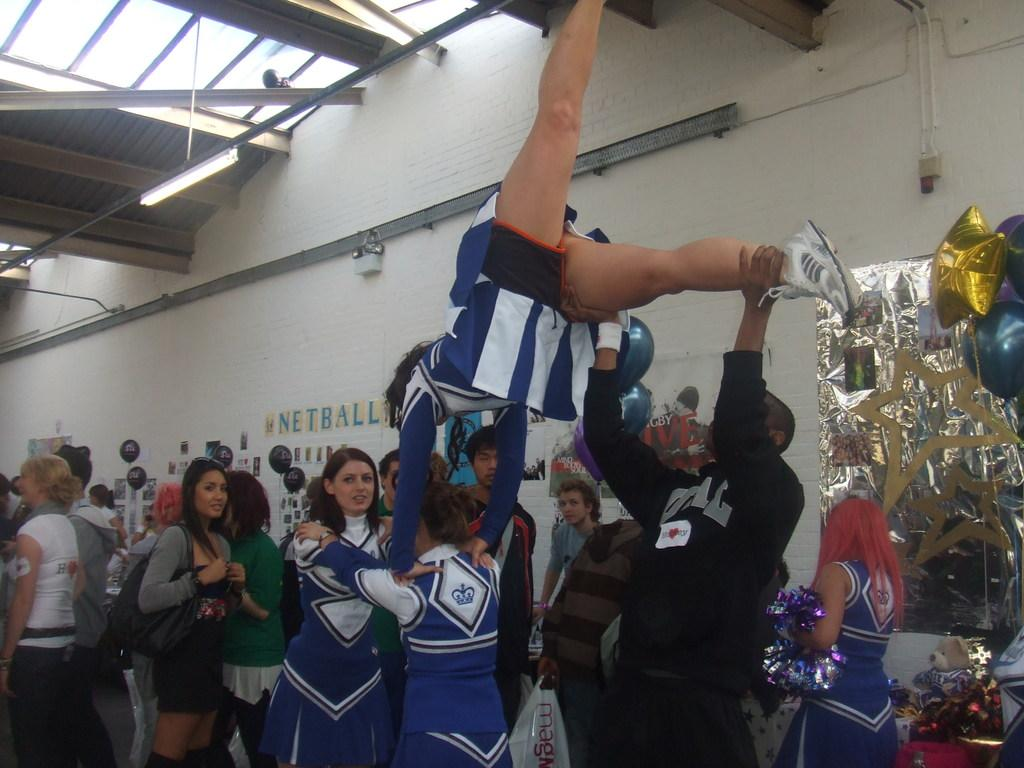<image>
Present a compact description of the photo's key features. Several cheerleaders demonstrate a stunt, in front of wall that has Netball written on it. 